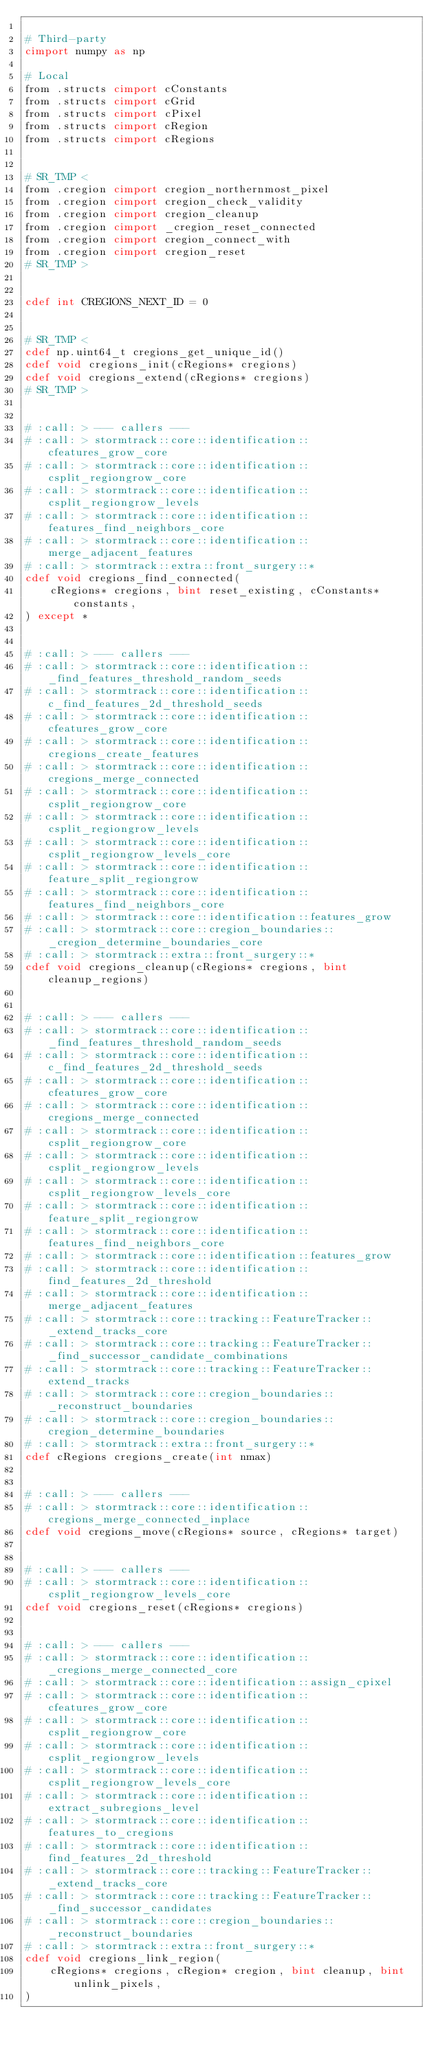<code> <loc_0><loc_0><loc_500><loc_500><_Cython_>
# Third-party
cimport numpy as np

# Local
from .structs cimport cConstants
from .structs cimport cGrid
from .structs cimport cPixel
from .structs cimport cRegion
from .structs cimport cRegions


# SR_TMP <
from .cregion cimport cregion_northernmost_pixel
from .cregion cimport cregion_check_validity
from .cregion cimport cregion_cleanup
from .cregion cimport _cregion_reset_connected
from .cregion cimport cregion_connect_with
from .cregion cimport cregion_reset
# SR_TMP >


cdef int CREGIONS_NEXT_ID = 0


# SR_TMP <
cdef np.uint64_t cregions_get_unique_id()
cdef void cregions_init(cRegions* cregions)
cdef void cregions_extend(cRegions* cregions)
# SR_TMP >


# :call: > --- callers ---
# :call: > stormtrack::core::identification::cfeatures_grow_core
# :call: > stormtrack::core::identification::csplit_regiongrow_core
# :call: > stormtrack::core::identification::csplit_regiongrow_levels
# :call: > stormtrack::core::identification::features_find_neighbors_core
# :call: > stormtrack::core::identification::merge_adjacent_features
# :call: > stormtrack::extra::front_surgery::*
cdef void cregions_find_connected(
    cRegions* cregions, bint reset_existing, cConstants* constants,
) except *


# :call: > --- callers ---
# :call: > stormtrack::core::identification::_find_features_threshold_random_seeds
# :call: > stormtrack::core::identification::c_find_features_2d_threshold_seeds
# :call: > stormtrack::core::identification::cfeatures_grow_core
# :call: > stormtrack::core::identification::cregions_create_features
# :call: > stormtrack::core::identification::cregions_merge_connected
# :call: > stormtrack::core::identification::csplit_regiongrow_core
# :call: > stormtrack::core::identification::csplit_regiongrow_levels
# :call: > stormtrack::core::identification::csplit_regiongrow_levels_core
# :call: > stormtrack::core::identification::feature_split_regiongrow
# :call: > stormtrack::core::identification::features_find_neighbors_core
# :call: > stormtrack::core::identification::features_grow
# :call: > stormtrack::core::cregion_boundaries::_cregion_determine_boundaries_core
# :call: > stormtrack::extra::front_surgery::*
cdef void cregions_cleanup(cRegions* cregions, bint cleanup_regions)


# :call: > --- callers ---
# :call: > stormtrack::core::identification::_find_features_threshold_random_seeds
# :call: > stormtrack::core::identification::c_find_features_2d_threshold_seeds
# :call: > stormtrack::core::identification::cfeatures_grow_core
# :call: > stormtrack::core::identification::cregions_merge_connected
# :call: > stormtrack::core::identification::csplit_regiongrow_core
# :call: > stormtrack::core::identification::csplit_regiongrow_levels
# :call: > stormtrack::core::identification::csplit_regiongrow_levels_core
# :call: > stormtrack::core::identification::feature_split_regiongrow
# :call: > stormtrack::core::identification::features_find_neighbors_core
# :call: > stormtrack::core::identification::features_grow
# :call: > stormtrack::core::identification::find_features_2d_threshold
# :call: > stormtrack::core::identification::merge_adjacent_features
# :call: > stormtrack::core::tracking::FeatureTracker::_extend_tracks_core
# :call: > stormtrack::core::tracking::FeatureTracker::_find_successor_candidate_combinations
# :call: > stormtrack::core::tracking::FeatureTracker::extend_tracks
# :call: > stormtrack::core::cregion_boundaries::_reconstruct_boundaries
# :call: > stormtrack::core::cregion_boundaries::cregion_determine_boundaries
# :call: > stormtrack::extra::front_surgery::*
cdef cRegions cregions_create(int nmax)


# :call: > --- callers ---
# :call: > stormtrack::core::identification::cregions_merge_connected_inplace
cdef void cregions_move(cRegions* source, cRegions* target)


# :call: > --- callers ---
# :call: > stormtrack::core::identification::csplit_regiongrow_levels_core
cdef void cregions_reset(cRegions* cregions)


# :call: > --- callers ---
# :call: > stormtrack::core::identification::_cregions_merge_connected_core
# :call: > stormtrack::core::identification::assign_cpixel
# :call: > stormtrack::core::identification::cfeatures_grow_core
# :call: > stormtrack::core::identification::csplit_regiongrow_core
# :call: > stormtrack::core::identification::csplit_regiongrow_levels
# :call: > stormtrack::core::identification::csplit_regiongrow_levels_core
# :call: > stormtrack::core::identification::extract_subregions_level
# :call: > stormtrack::core::identification::features_to_cregions
# :call: > stormtrack::core::identification::find_features_2d_threshold
# :call: > stormtrack::core::tracking::FeatureTracker::_extend_tracks_core
# :call: > stormtrack::core::tracking::FeatureTracker::_find_successor_candidates
# :call: > stormtrack::core::cregion_boundaries::_reconstruct_boundaries
# :call: > stormtrack::extra::front_surgery::*
cdef void cregions_link_region(
    cRegions* cregions, cRegion* cregion, bint cleanup, bint unlink_pixels,
)
</code> 